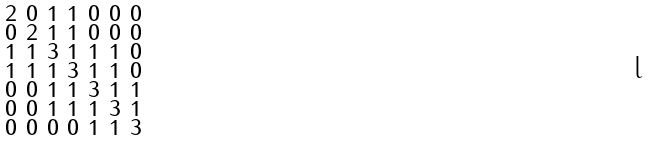<formula> <loc_0><loc_0><loc_500><loc_500>\begin{smallmatrix} 2 & 0 & 1 & 1 & 0 & 0 & 0 \\ 0 & 2 & 1 & 1 & 0 & 0 & 0 \\ 1 & 1 & 3 & 1 & 1 & 1 & 0 \\ 1 & 1 & 1 & 3 & 1 & 1 & 0 \\ 0 & 0 & 1 & 1 & 3 & 1 & 1 \\ 0 & 0 & 1 & 1 & 1 & 3 & 1 \\ 0 & 0 & 0 & 0 & 1 & 1 & 3 \end{smallmatrix}</formula> 